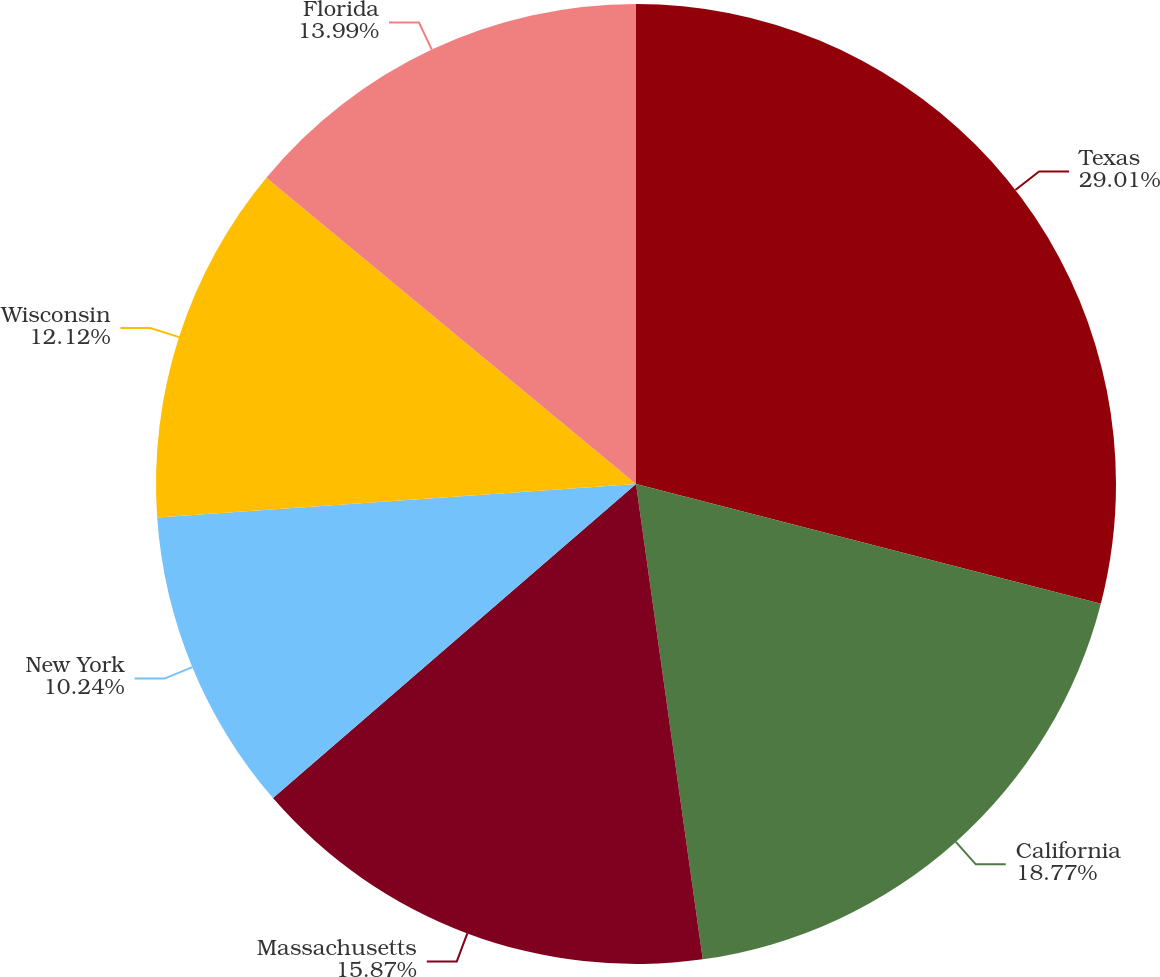<chart> <loc_0><loc_0><loc_500><loc_500><pie_chart><fcel>Texas<fcel>California<fcel>Massachusetts<fcel>New York<fcel>Wisconsin<fcel>Florida<nl><fcel>29.01%<fcel>18.77%<fcel>15.87%<fcel>10.24%<fcel>12.12%<fcel>13.99%<nl></chart> 